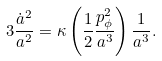<formula> <loc_0><loc_0><loc_500><loc_500>3 \frac { \dot { a } ^ { 2 } } { a ^ { 2 } } = \kappa \left ( \frac { 1 } { 2 } \frac { p _ { \phi } ^ { 2 } } { a ^ { 3 } } \right ) \frac { 1 } { a ^ { 3 } } .</formula> 